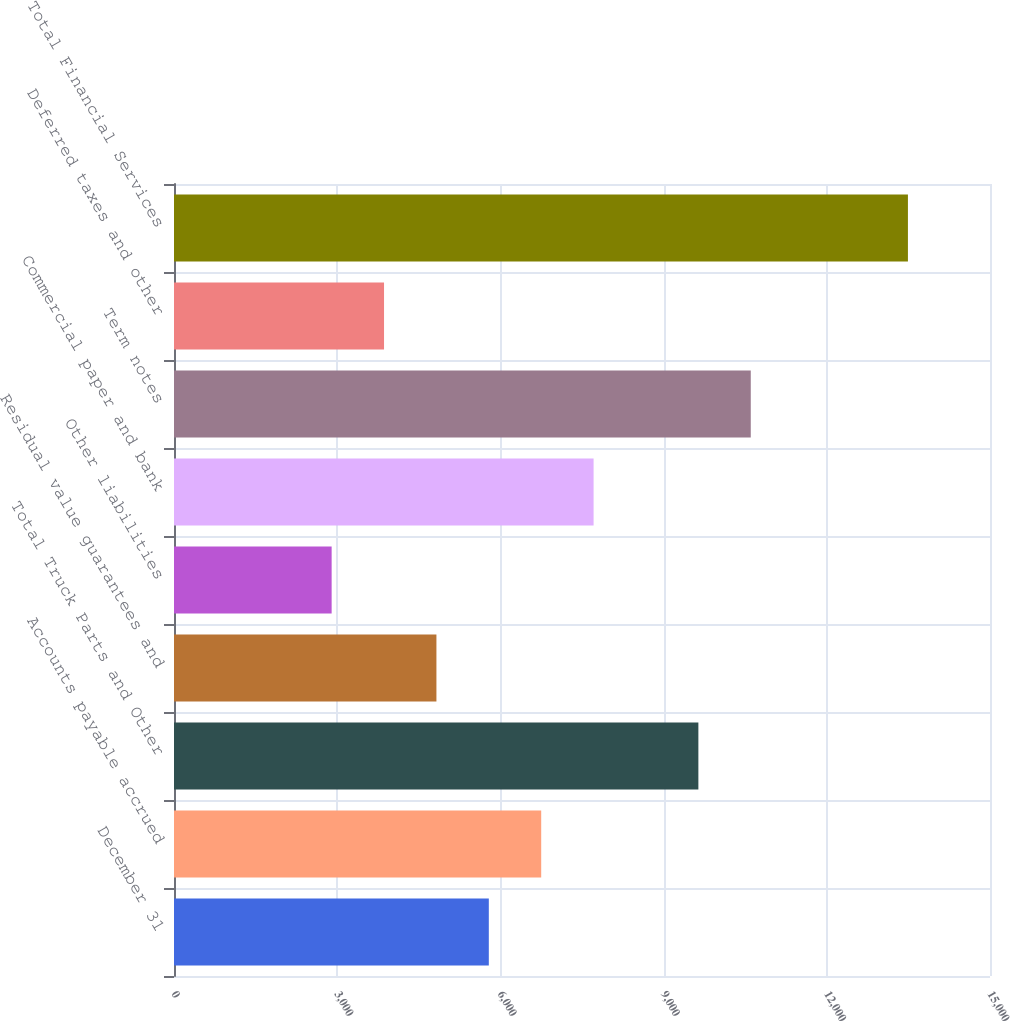Convert chart. <chart><loc_0><loc_0><loc_500><loc_500><bar_chart><fcel>December 31<fcel>Accounts payable accrued<fcel>Total Truck Parts and Other<fcel>Residual value guarantees and<fcel>Other liabilities<fcel>Commercial paper and bank<fcel>Term notes<fcel>Deferred taxes and other<fcel>Total Financial Services<nl><fcel>5787<fcel>6750.05<fcel>9639.2<fcel>4823.95<fcel>2897.85<fcel>7713.1<fcel>10602.2<fcel>3860.9<fcel>13491.4<nl></chart> 